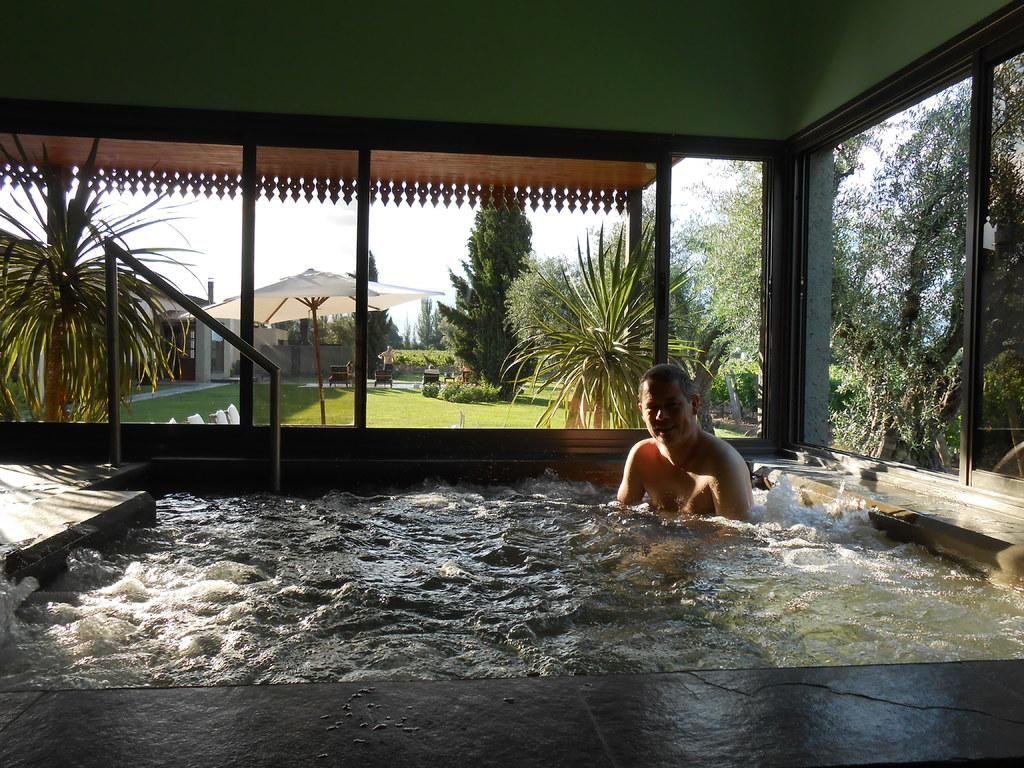What can be seen in the image? There is a pool in the image, and a man is bathing in it. What is present in the background of the image? There is an umbrella, trees, and a garden in the background of the image. How is the sky depicted in the image? The sky is visible in the image and appears to be clear. Can you tell me how many times the man sneezes in the image? There is no indication of the man sneezing in the image; he is simply bathing in the pool. What type of milk is being used in the image? There is no milk present in the image. 